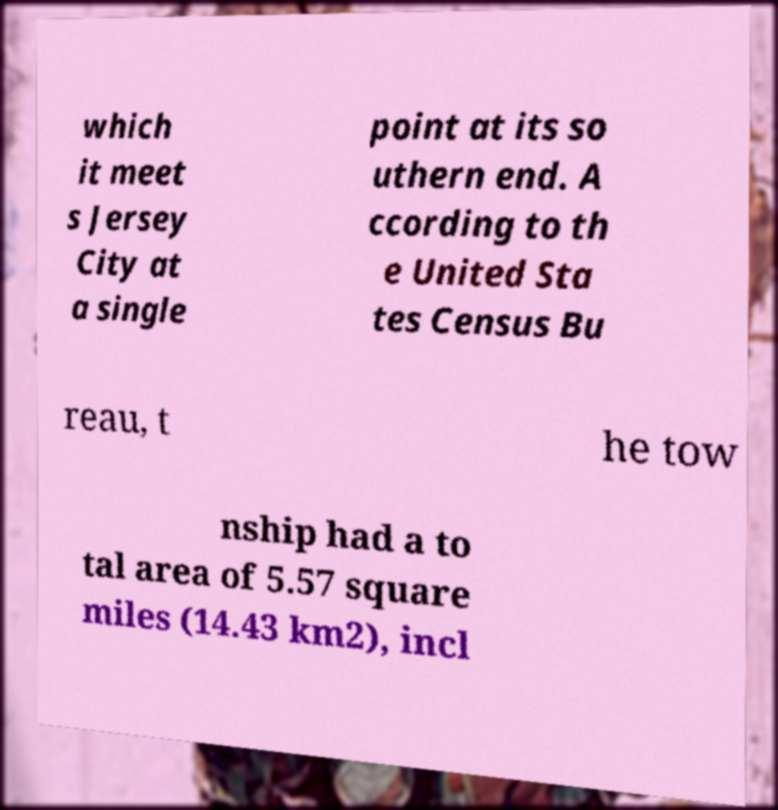I need the written content from this picture converted into text. Can you do that? which it meet s Jersey City at a single point at its so uthern end. A ccording to th e United Sta tes Census Bu reau, t he tow nship had a to tal area of 5.57 square miles (14.43 km2), incl 